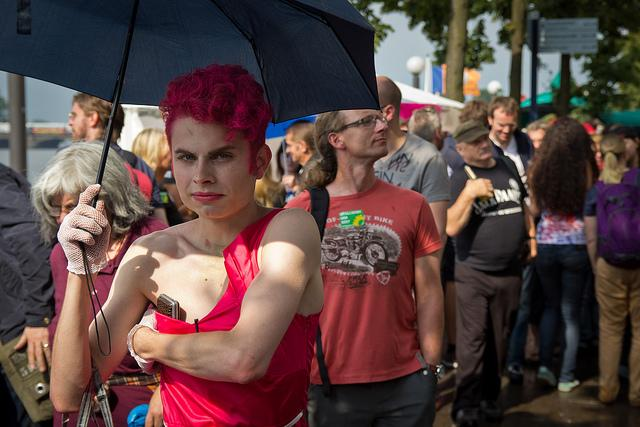Why does the man holding the umbrella have very red lips?

Choices:
A) he's sick
B) chapstick
C) genetics
D) lipstick lipstick 